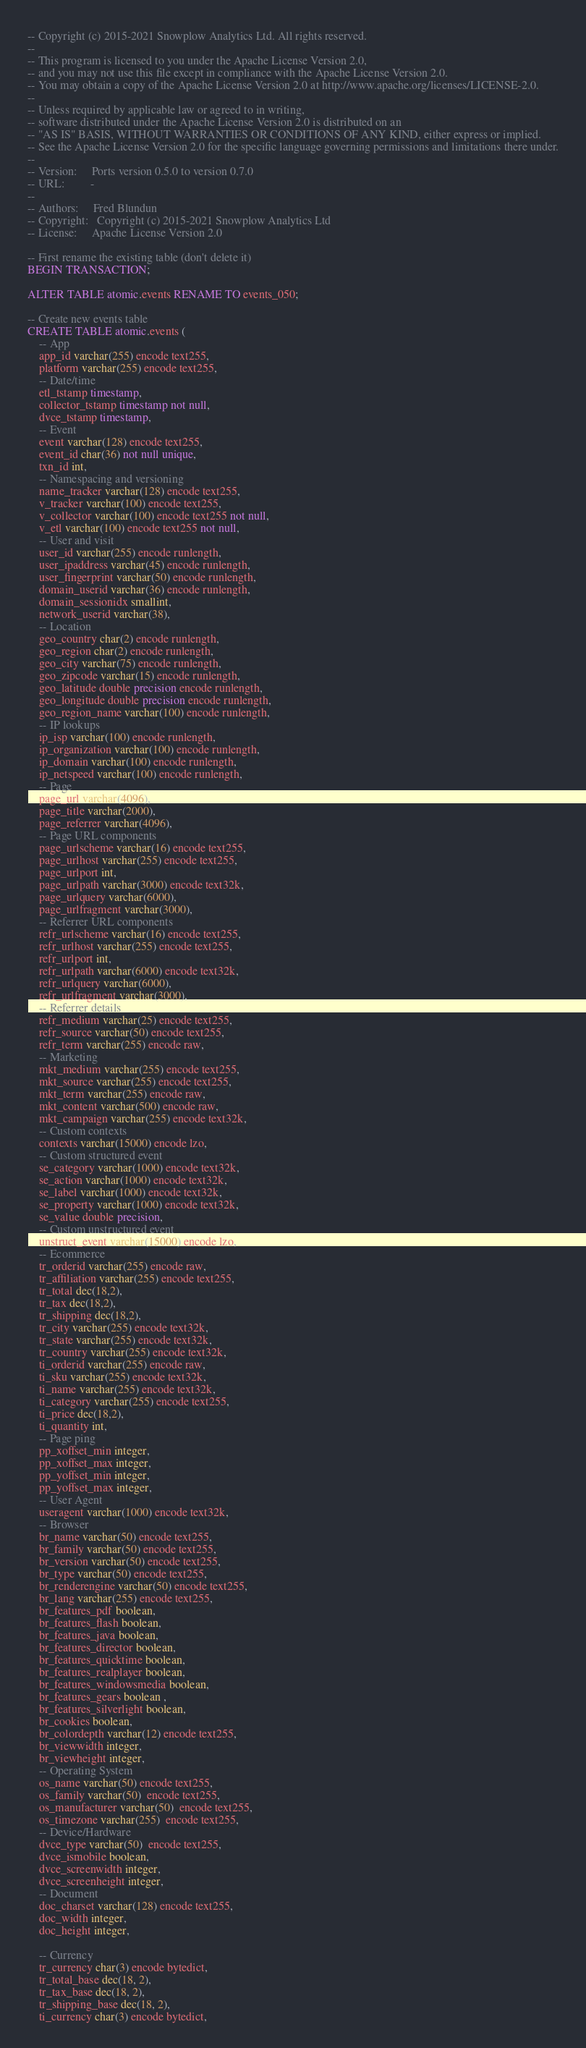Convert code to text. <code><loc_0><loc_0><loc_500><loc_500><_SQL_>-- Copyright (c) 2015-2021 Snowplow Analytics Ltd. All rights reserved.
--
-- This program is licensed to you under the Apache License Version 2.0,
-- and you may not use this file except in compliance with the Apache License Version 2.0.
-- You may obtain a copy of the Apache License Version 2.0 at http://www.apache.org/licenses/LICENSE-2.0.
--
-- Unless required by applicable law or agreed to in writing,
-- software distributed under the Apache License Version 2.0 is distributed on an
-- "AS IS" BASIS, WITHOUT WARRANTIES OR CONDITIONS OF ANY KIND, either express or implied.
-- See the Apache License Version 2.0 for the specific language governing permissions and limitations there under.
--
-- Version:     Ports version 0.5.0 to version 0.7.0
-- URL:         -
--
-- Authors:     Fred Blundun
-- Copyright:   Copyright (c) 2015-2021 Snowplow Analytics Ltd
-- License:     Apache License Version 2.0

-- First rename the existing table (don't delete it)
BEGIN TRANSACTION;

ALTER TABLE atomic.events RENAME TO events_050;

-- Create new events table
CREATE TABLE atomic.events (
	-- App
	app_id varchar(255) encode text255,
	platform varchar(255) encode text255,
	-- Date/time
	etl_tstamp timestamp,
	collector_tstamp timestamp not null,
	dvce_tstamp timestamp,
	-- Event
	event varchar(128) encode text255,
	event_id char(36) not null unique,
	txn_id int,
	-- Namespacing and versioning
	name_tracker varchar(128) encode text255,
	v_tracker varchar(100) encode text255,
	v_collector varchar(100) encode text255 not null,
	v_etl varchar(100) encode text255 not null,
	-- User and visit
	user_id varchar(255) encode runlength,
	user_ipaddress varchar(45) encode runlength,
	user_fingerprint varchar(50) encode runlength,
	domain_userid varchar(36) encode runlength,
	domain_sessionidx smallint,
	network_userid varchar(38),
	-- Location
	geo_country char(2) encode runlength,
	geo_region char(2) encode runlength,
	geo_city varchar(75) encode runlength,
	geo_zipcode varchar(15) encode runlength,
	geo_latitude double precision encode runlength,
	geo_longitude double precision encode runlength,
	geo_region_name varchar(100) encode runlength,
	-- IP lookups
	ip_isp varchar(100) encode runlength,
	ip_organization varchar(100) encode runlength,
	ip_domain varchar(100) encode runlength,
	ip_netspeed varchar(100) encode runlength,
	-- Page
	page_url varchar(4096),
	page_title varchar(2000),
	page_referrer varchar(4096),
	-- Page URL components
	page_urlscheme varchar(16) encode text255,
	page_urlhost varchar(255) encode text255,
	page_urlport int,
	page_urlpath varchar(3000) encode text32k,
	page_urlquery varchar(6000),
	page_urlfragment varchar(3000),
	-- Referrer URL components
	refr_urlscheme varchar(16) encode text255,
	refr_urlhost varchar(255) encode text255,
	refr_urlport int,
	refr_urlpath varchar(6000) encode text32k,
	refr_urlquery varchar(6000),
	refr_urlfragment varchar(3000),
	-- Referrer details
	refr_medium varchar(25) encode text255,
	refr_source varchar(50) encode text255,
	refr_term varchar(255) encode raw,
	-- Marketing
	mkt_medium varchar(255) encode text255,
	mkt_source varchar(255) encode text255,
	mkt_term varchar(255) encode raw,
	mkt_content varchar(500) encode raw,
	mkt_campaign varchar(255) encode text32k,
	-- Custom contexts
	contexts varchar(15000) encode lzo,
	-- Custom structured event
	se_category varchar(1000) encode text32k,
	se_action varchar(1000) encode text32k,
	se_label varchar(1000) encode text32k,
	se_property varchar(1000) encode text32k,
	se_value double precision,
	-- Custom unstructured event
	unstruct_event varchar(15000) encode lzo,
	-- Ecommerce
	tr_orderid varchar(255) encode raw,
	tr_affiliation varchar(255) encode text255,
	tr_total dec(18,2),
	tr_tax dec(18,2),
	tr_shipping dec(18,2),
	tr_city varchar(255) encode text32k,
	tr_state varchar(255) encode text32k,
	tr_country varchar(255) encode text32k,
	ti_orderid varchar(255) encode raw,
	ti_sku varchar(255) encode text32k,
	ti_name varchar(255) encode text32k,
	ti_category varchar(255) encode text255,
	ti_price dec(18,2),
	ti_quantity int,
	-- Page ping
	pp_xoffset_min integer,
	pp_xoffset_max integer,
	pp_yoffset_min integer,
	pp_yoffset_max integer,
	-- User Agent
	useragent varchar(1000) encode text32k,
	-- Browser
	br_name varchar(50) encode text255,
	br_family varchar(50) encode text255,
	br_version varchar(50) encode text255,
	br_type varchar(50) encode text255,
	br_renderengine varchar(50) encode text255,
	br_lang varchar(255) encode text255,
	br_features_pdf boolean,
	br_features_flash boolean,
	br_features_java boolean,
	br_features_director boolean,
	br_features_quicktime boolean,
	br_features_realplayer boolean,
	br_features_windowsmedia boolean,
	br_features_gears boolean ,
	br_features_silverlight boolean,
	br_cookies boolean,
	br_colordepth varchar(12) encode text255,
	br_viewwidth integer,
	br_viewheight integer,
	-- Operating System
	os_name varchar(50) encode text255,
	os_family varchar(50)  encode text255,
	os_manufacturer varchar(50)  encode text255,
	os_timezone varchar(255)  encode text255,
	-- Device/Hardware
	dvce_type varchar(50)  encode text255,
	dvce_ismobile boolean,
	dvce_screenwidth integer,
	dvce_screenheight integer,
	-- Document
	doc_charset varchar(128) encode text255,
	doc_width integer,
	doc_height integer,

	-- Currency
	tr_currency char(3) encode bytedict,
	tr_total_base dec(18, 2),
	tr_tax_base dec(18, 2),
	tr_shipping_base dec(18, 2),
	ti_currency char(3) encode bytedict,</code> 